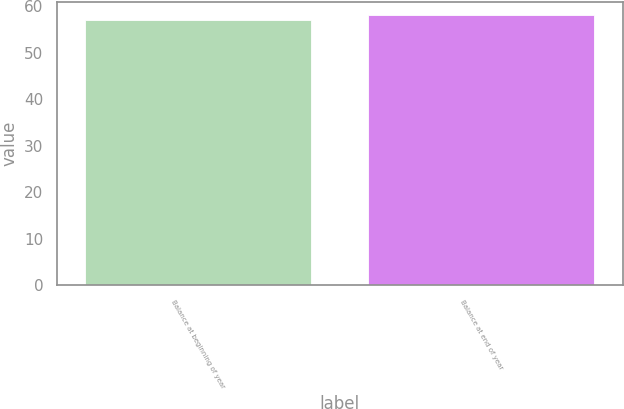Convert chart. <chart><loc_0><loc_0><loc_500><loc_500><bar_chart><fcel>Balance at beginning of year<fcel>Balance at end of year<nl><fcel>57<fcel>58<nl></chart> 